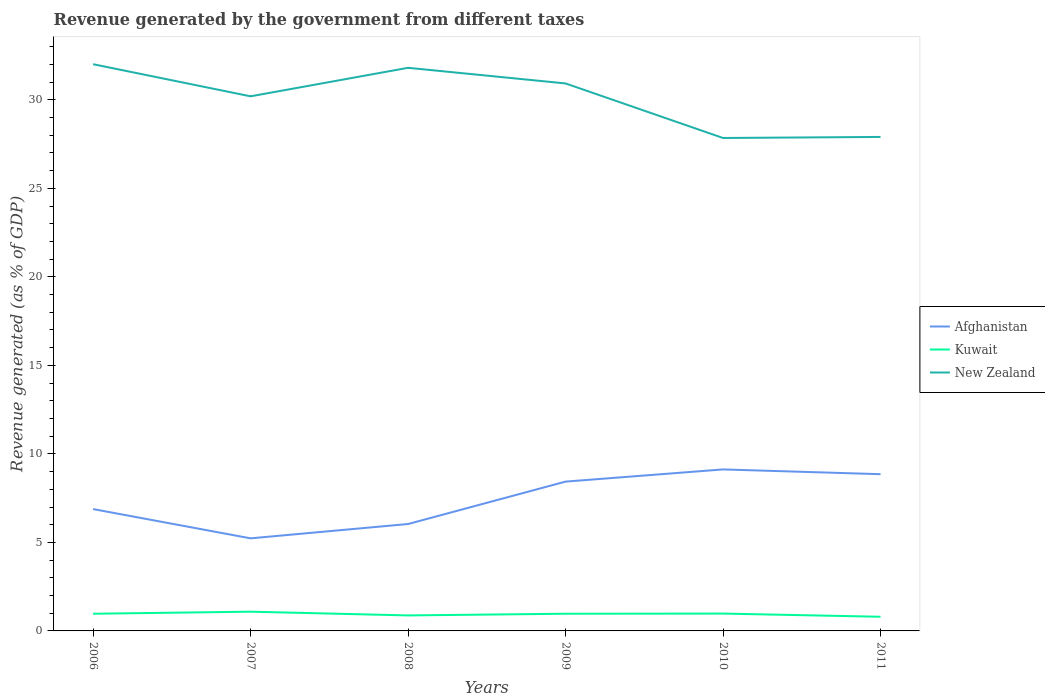How many different coloured lines are there?
Give a very brief answer. 3. Does the line corresponding to Kuwait intersect with the line corresponding to Afghanistan?
Ensure brevity in your answer.  No. Is the number of lines equal to the number of legend labels?
Offer a terse response. Yes. Across all years, what is the maximum revenue generated by the government in Kuwait?
Provide a short and direct response. 0.8. What is the total revenue generated by the government in Afghanistan in the graph?
Give a very brief answer. -1.55. What is the difference between the highest and the second highest revenue generated by the government in New Zealand?
Ensure brevity in your answer.  4.17. What is the difference between the highest and the lowest revenue generated by the government in Kuwait?
Offer a terse response. 4. What is the difference between two consecutive major ticks on the Y-axis?
Your answer should be very brief. 5. Does the graph contain grids?
Provide a short and direct response. No. Where does the legend appear in the graph?
Make the answer very short. Center right. How many legend labels are there?
Provide a short and direct response. 3. What is the title of the graph?
Ensure brevity in your answer.  Revenue generated by the government from different taxes. What is the label or title of the X-axis?
Ensure brevity in your answer.  Years. What is the label or title of the Y-axis?
Your answer should be compact. Revenue generated (as % of GDP). What is the Revenue generated (as % of GDP) of Afghanistan in 2006?
Offer a very short reply. 6.88. What is the Revenue generated (as % of GDP) in Kuwait in 2006?
Provide a short and direct response. 0.97. What is the Revenue generated (as % of GDP) of New Zealand in 2006?
Your response must be concise. 32.01. What is the Revenue generated (as % of GDP) of Afghanistan in 2007?
Give a very brief answer. 5.23. What is the Revenue generated (as % of GDP) in Kuwait in 2007?
Your answer should be very brief. 1.09. What is the Revenue generated (as % of GDP) in New Zealand in 2007?
Make the answer very short. 30.2. What is the Revenue generated (as % of GDP) of Afghanistan in 2008?
Offer a terse response. 6.04. What is the Revenue generated (as % of GDP) of Kuwait in 2008?
Ensure brevity in your answer.  0.88. What is the Revenue generated (as % of GDP) of New Zealand in 2008?
Ensure brevity in your answer.  31.81. What is the Revenue generated (as % of GDP) of Afghanistan in 2009?
Offer a very short reply. 8.43. What is the Revenue generated (as % of GDP) in Kuwait in 2009?
Ensure brevity in your answer.  0.97. What is the Revenue generated (as % of GDP) in New Zealand in 2009?
Provide a succinct answer. 30.93. What is the Revenue generated (as % of GDP) of Afghanistan in 2010?
Keep it short and to the point. 9.12. What is the Revenue generated (as % of GDP) of Kuwait in 2010?
Your answer should be very brief. 0.98. What is the Revenue generated (as % of GDP) of New Zealand in 2010?
Keep it short and to the point. 27.85. What is the Revenue generated (as % of GDP) in Afghanistan in 2011?
Offer a very short reply. 8.85. What is the Revenue generated (as % of GDP) of Kuwait in 2011?
Keep it short and to the point. 0.8. What is the Revenue generated (as % of GDP) in New Zealand in 2011?
Ensure brevity in your answer.  27.91. Across all years, what is the maximum Revenue generated (as % of GDP) in Afghanistan?
Keep it short and to the point. 9.12. Across all years, what is the maximum Revenue generated (as % of GDP) of Kuwait?
Your response must be concise. 1.09. Across all years, what is the maximum Revenue generated (as % of GDP) of New Zealand?
Provide a succinct answer. 32.01. Across all years, what is the minimum Revenue generated (as % of GDP) of Afghanistan?
Provide a succinct answer. 5.23. Across all years, what is the minimum Revenue generated (as % of GDP) in Kuwait?
Make the answer very short. 0.8. Across all years, what is the minimum Revenue generated (as % of GDP) of New Zealand?
Keep it short and to the point. 27.85. What is the total Revenue generated (as % of GDP) in Afghanistan in the graph?
Keep it short and to the point. 44.57. What is the total Revenue generated (as % of GDP) in Kuwait in the graph?
Make the answer very short. 5.68. What is the total Revenue generated (as % of GDP) of New Zealand in the graph?
Offer a terse response. 180.71. What is the difference between the Revenue generated (as % of GDP) of Afghanistan in 2006 and that in 2007?
Give a very brief answer. 1.65. What is the difference between the Revenue generated (as % of GDP) in Kuwait in 2006 and that in 2007?
Your answer should be very brief. -0.12. What is the difference between the Revenue generated (as % of GDP) of New Zealand in 2006 and that in 2007?
Provide a short and direct response. 1.81. What is the difference between the Revenue generated (as % of GDP) in Afghanistan in 2006 and that in 2008?
Provide a succinct answer. 0.84. What is the difference between the Revenue generated (as % of GDP) in Kuwait in 2006 and that in 2008?
Give a very brief answer. 0.09. What is the difference between the Revenue generated (as % of GDP) in New Zealand in 2006 and that in 2008?
Offer a very short reply. 0.2. What is the difference between the Revenue generated (as % of GDP) of Afghanistan in 2006 and that in 2009?
Keep it short and to the point. -1.55. What is the difference between the Revenue generated (as % of GDP) in Kuwait in 2006 and that in 2009?
Your response must be concise. -0. What is the difference between the Revenue generated (as % of GDP) in New Zealand in 2006 and that in 2009?
Give a very brief answer. 1.09. What is the difference between the Revenue generated (as % of GDP) in Afghanistan in 2006 and that in 2010?
Keep it short and to the point. -2.24. What is the difference between the Revenue generated (as % of GDP) of Kuwait in 2006 and that in 2010?
Make the answer very short. -0.01. What is the difference between the Revenue generated (as % of GDP) in New Zealand in 2006 and that in 2010?
Provide a short and direct response. 4.17. What is the difference between the Revenue generated (as % of GDP) of Afghanistan in 2006 and that in 2011?
Ensure brevity in your answer.  -1.97. What is the difference between the Revenue generated (as % of GDP) in Kuwait in 2006 and that in 2011?
Your answer should be very brief. 0.17. What is the difference between the Revenue generated (as % of GDP) in New Zealand in 2006 and that in 2011?
Offer a terse response. 4.11. What is the difference between the Revenue generated (as % of GDP) in Afghanistan in 2007 and that in 2008?
Make the answer very short. -0.81. What is the difference between the Revenue generated (as % of GDP) in Kuwait in 2007 and that in 2008?
Offer a terse response. 0.21. What is the difference between the Revenue generated (as % of GDP) in New Zealand in 2007 and that in 2008?
Provide a short and direct response. -1.61. What is the difference between the Revenue generated (as % of GDP) of Afghanistan in 2007 and that in 2009?
Offer a terse response. -3.21. What is the difference between the Revenue generated (as % of GDP) in Kuwait in 2007 and that in 2009?
Offer a terse response. 0.12. What is the difference between the Revenue generated (as % of GDP) of New Zealand in 2007 and that in 2009?
Provide a succinct answer. -0.73. What is the difference between the Revenue generated (as % of GDP) in Afghanistan in 2007 and that in 2010?
Your response must be concise. -3.89. What is the difference between the Revenue generated (as % of GDP) in Kuwait in 2007 and that in 2010?
Your answer should be very brief. 0.11. What is the difference between the Revenue generated (as % of GDP) of New Zealand in 2007 and that in 2010?
Ensure brevity in your answer.  2.35. What is the difference between the Revenue generated (as % of GDP) in Afghanistan in 2007 and that in 2011?
Your answer should be very brief. -3.62. What is the difference between the Revenue generated (as % of GDP) of Kuwait in 2007 and that in 2011?
Offer a terse response. 0.29. What is the difference between the Revenue generated (as % of GDP) in New Zealand in 2007 and that in 2011?
Keep it short and to the point. 2.29. What is the difference between the Revenue generated (as % of GDP) in Afghanistan in 2008 and that in 2009?
Provide a succinct answer. -2.4. What is the difference between the Revenue generated (as % of GDP) of Kuwait in 2008 and that in 2009?
Make the answer very short. -0.1. What is the difference between the Revenue generated (as % of GDP) of New Zealand in 2008 and that in 2009?
Ensure brevity in your answer.  0.88. What is the difference between the Revenue generated (as % of GDP) of Afghanistan in 2008 and that in 2010?
Give a very brief answer. -3.08. What is the difference between the Revenue generated (as % of GDP) of Kuwait in 2008 and that in 2010?
Keep it short and to the point. -0.1. What is the difference between the Revenue generated (as % of GDP) of New Zealand in 2008 and that in 2010?
Provide a short and direct response. 3.96. What is the difference between the Revenue generated (as % of GDP) in Afghanistan in 2008 and that in 2011?
Offer a very short reply. -2.82. What is the difference between the Revenue generated (as % of GDP) in Kuwait in 2008 and that in 2011?
Your response must be concise. 0.08. What is the difference between the Revenue generated (as % of GDP) of New Zealand in 2008 and that in 2011?
Your response must be concise. 3.91. What is the difference between the Revenue generated (as % of GDP) of Afghanistan in 2009 and that in 2010?
Make the answer very short. -0.69. What is the difference between the Revenue generated (as % of GDP) of Kuwait in 2009 and that in 2010?
Offer a terse response. -0.01. What is the difference between the Revenue generated (as % of GDP) in New Zealand in 2009 and that in 2010?
Your answer should be very brief. 3.08. What is the difference between the Revenue generated (as % of GDP) of Afghanistan in 2009 and that in 2011?
Ensure brevity in your answer.  -0.42. What is the difference between the Revenue generated (as % of GDP) of Kuwait in 2009 and that in 2011?
Offer a very short reply. 0.17. What is the difference between the Revenue generated (as % of GDP) of New Zealand in 2009 and that in 2011?
Your response must be concise. 3.02. What is the difference between the Revenue generated (as % of GDP) in Afghanistan in 2010 and that in 2011?
Give a very brief answer. 0.27. What is the difference between the Revenue generated (as % of GDP) in Kuwait in 2010 and that in 2011?
Your answer should be compact. 0.18. What is the difference between the Revenue generated (as % of GDP) of New Zealand in 2010 and that in 2011?
Ensure brevity in your answer.  -0.06. What is the difference between the Revenue generated (as % of GDP) in Afghanistan in 2006 and the Revenue generated (as % of GDP) in Kuwait in 2007?
Make the answer very short. 5.8. What is the difference between the Revenue generated (as % of GDP) in Afghanistan in 2006 and the Revenue generated (as % of GDP) in New Zealand in 2007?
Make the answer very short. -23.32. What is the difference between the Revenue generated (as % of GDP) of Kuwait in 2006 and the Revenue generated (as % of GDP) of New Zealand in 2007?
Your response must be concise. -29.23. What is the difference between the Revenue generated (as % of GDP) of Afghanistan in 2006 and the Revenue generated (as % of GDP) of Kuwait in 2008?
Your response must be concise. 6.01. What is the difference between the Revenue generated (as % of GDP) in Afghanistan in 2006 and the Revenue generated (as % of GDP) in New Zealand in 2008?
Offer a terse response. -24.93. What is the difference between the Revenue generated (as % of GDP) in Kuwait in 2006 and the Revenue generated (as % of GDP) in New Zealand in 2008?
Offer a very short reply. -30.84. What is the difference between the Revenue generated (as % of GDP) in Afghanistan in 2006 and the Revenue generated (as % of GDP) in Kuwait in 2009?
Provide a succinct answer. 5.91. What is the difference between the Revenue generated (as % of GDP) of Afghanistan in 2006 and the Revenue generated (as % of GDP) of New Zealand in 2009?
Give a very brief answer. -24.05. What is the difference between the Revenue generated (as % of GDP) of Kuwait in 2006 and the Revenue generated (as % of GDP) of New Zealand in 2009?
Your answer should be compact. -29.96. What is the difference between the Revenue generated (as % of GDP) of Afghanistan in 2006 and the Revenue generated (as % of GDP) of Kuwait in 2010?
Give a very brief answer. 5.9. What is the difference between the Revenue generated (as % of GDP) of Afghanistan in 2006 and the Revenue generated (as % of GDP) of New Zealand in 2010?
Make the answer very short. -20.96. What is the difference between the Revenue generated (as % of GDP) of Kuwait in 2006 and the Revenue generated (as % of GDP) of New Zealand in 2010?
Your response must be concise. -26.88. What is the difference between the Revenue generated (as % of GDP) of Afghanistan in 2006 and the Revenue generated (as % of GDP) of Kuwait in 2011?
Provide a succinct answer. 6.08. What is the difference between the Revenue generated (as % of GDP) of Afghanistan in 2006 and the Revenue generated (as % of GDP) of New Zealand in 2011?
Your answer should be compact. -21.02. What is the difference between the Revenue generated (as % of GDP) in Kuwait in 2006 and the Revenue generated (as % of GDP) in New Zealand in 2011?
Offer a very short reply. -26.94. What is the difference between the Revenue generated (as % of GDP) of Afghanistan in 2007 and the Revenue generated (as % of GDP) of Kuwait in 2008?
Offer a terse response. 4.35. What is the difference between the Revenue generated (as % of GDP) in Afghanistan in 2007 and the Revenue generated (as % of GDP) in New Zealand in 2008?
Make the answer very short. -26.58. What is the difference between the Revenue generated (as % of GDP) of Kuwait in 2007 and the Revenue generated (as % of GDP) of New Zealand in 2008?
Your response must be concise. -30.72. What is the difference between the Revenue generated (as % of GDP) of Afghanistan in 2007 and the Revenue generated (as % of GDP) of Kuwait in 2009?
Offer a terse response. 4.26. What is the difference between the Revenue generated (as % of GDP) of Afghanistan in 2007 and the Revenue generated (as % of GDP) of New Zealand in 2009?
Provide a succinct answer. -25.7. What is the difference between the Revenue generated (as % of GDP) in Kuwait in 2007 and the Revenue generated (as % of GDP) in New Zealand in 2009?
Your answer should be very brief. -29.84. What is the difference between the Revenue generated (as % of GDP) of Afghanistan in 2007 and the Revenue generated (as % of GDP) of Kuwait in 2010?
Your response must be concise. 4.25. What is the difference between the Revenue generated (as % of GDP) of Afghanistan in 2007 and the Revenue generated (as % of GDP) of New Zealand in 2010?
Your answer should be very brief. -22.62. What is the difference between the Revenue generated (as % of GDP) of Kuwait in 2007 and the Revenue generated (as % of GDP) of New Zealand in 2010?
Ensure brevity in your answer.  -26.76. What is the difference between the Revenue generated (as % of GDP) in Afghanistan in 2007 and the Revenue generated (as % of GDP) in Kuwait in 2011?
Make the answer very short. 4.43. What is the difference between the Revenue generated (as % of GDP) of Afghanistan in 2007 and the Revenue generated (as % of GDP) of New Zealand in 2011?
Your answer should be compact. -22.68. What is the difference between the Revenue generated (as % of GDP) of Kuwait in 2007 and the Revenue generated (as % of GDP) of New Zealand in 2011?
Ensure brevity in your answer.  -26.82. What is the difference between the Revenue generated (as % of GDP) of Afghanistan in 2008 and the Revenue generated (as % of GDP) of Kuwait in 2009?
Provide a succinct answer. 5.07. What is the difference between the Revenue generated (as % of GDP) of Afghanistan in 2008 and the Revenue generated (as % of GDP) of New Zealand in 2009?
Ensure brevity in your answer.  -24.89. What is the difference between the Revenue generated (as % of GDP) of Kuwait in 2008 and the Revenue generated (as % of GDP) of New Zealand in 2009?
Your answer should be compact. -30.05. What is the difference between the Revenue generated (as % of GDP) of Afghanistan in 2008 and the Revenue generated (as % of GDP) of Kuwait in 2010?
Make the answer very short. 5.06. What is the difference between the Revenue generated (as % of GDP) of Afghanistan in 2008 and the Revenue generated (as % of GDP) of New Zealand in 2010?
Your answer should be compact. -21.81. What is the difference between the Revenue generated (as % of GDP) in Kuwait in 2008 and the Revenue generated (as % of GDP) in New Zealand in 2010?
Ensure brevity in your answer.  -26.97. What is the difference between the Revenue generated (as % of GDP) of Afghanistan in 2008 and the Revenue generated (as % of GDP) of Kuwait in 2011?
Your answer should be compact. 5.24. What is the difference between the Revenue generated (as % of GDP) of Afghanistan in 2008 and the Revenue generated (as % of GDP) of New Zealand in 2011?
Keep it short and to the point. -21.87. What is the difference between the Revenue generated (as % of GDP) in Kuwait in 2008 and the Revenue generated (as % of GDP) in New Zealand in 2011?
Ensure brevity in your answer.  -27.03. What is the difference between the Revenue generated (as % of GDP) in Afghanistan in 2009 and the Revenue generated (as % of GDP) in Kuwait in 2010?
Keep it short and to the point. 7.46. What is the difference between the Revenue generated (as % of GDP) of Afghanistan in 2009 and the Revenue generated (as % of GDP) of New Zealand in 2010?
Offer a terse response. -19.41. What is the difference between the Revenue generated (as % of GDP) of Kuwait in 2009 and the Revenue generated (as % of GDP) of New Zealand in 2010?
Offer a terse response. -26.88. What is the difference between the Revenue generated (as % of GDP) of Afghanistan in 2009 and the Revenue generated (as % of GDP) of Kuwait in 2011?
Offer a very short reply. 7.64. What is the difference between the Revenue generated (as % of GDP) of Afghanistan in 2009 and the Revenue generated (as % of GDP) of New Zealand in 2011?
Your answer should be very brief. -19.47. What is the difference between the Revenue generated (as % of GDP) in Kuwait in 2009 and the Revenue generated (as % of GDP) in New Zealand in 2011?
Your answer should be very brief. -26.93. What is the difference between the Revenue generated (as % of GDP) of Afghanistan in 2010 and the Revenue generated (as % of GDP) of Kuwait in 2011?
Your answer should be very brief. 8.32. What is the difference between the Revenue generated (as % of GDP) in Afghanistan in 2010 and the Revenue generated (as % of GDP) in New Zealand in 2011?
Offer a terse response. -18.78. What is the difference between the Revenue generated (as % of GDP) in Kuwait in 2010 and the Revenue generated (as % of GDP) in New Zealand in 2011?
Your response must be concise. -26.93. What is the average Revenue generated (as % of GDP) of Afghanistan per year?
Give a very brief answer. 7.43. What is the average Revenue generated (as % of GDP) of Kuwait per year?
Keep it short and to the point. 0.95. What is the average Revenue generated (as % of GDP) in New Zealand per year?
Your response must be concise. 30.12. In the year 2006, what is the difference between the Revenue generated (as % of GDP) of Afghanistan and Revenue generated (as % of GDP) of Kuwait?
Offer a terse response. 5.91. In the year 2006, what is the difference between the Revenue generated (as % of GDP) of Afghanistan and Revenue generated (as % of GDP) of New Zealand?
Your answer should be very brief. -25.13. In the year 2006, what is the difference between the Revenue generated (as % of GDP) in Kuwait and Revenue generated (as % of GDP) in New Zealand?
Your answer should be very brief. -31.04. In the year 2007, what is the difference between the Revenue generated (as % of GDP) of Afghanistan and Revenue generated (as % of GDP) of Kuwait?
Your answer should be very brief. 4.14. In the year 2007, what is the difference between the Revenue generated (as % of GDP) of Afghanistan and Revenue generated (as % of GDP) of New Zealand?
Ensure brevity in your answer.  -24.97. In the year 2007, what is the difference between the Revenue generated (as % of GDP) of Kuwait and Revenue generated (as % of GDP) of New Zealand?
Your response must be concise. -29.11. In the year 2008, what is the difference between the Revenue generated (as % of GDP) of Afghanistan and Revenue generated (as % of GDP) of Kuwait?
Ensure brevity in your answer.  5.16. In the year 2008, what is the difference between the Revenue generated (as % of GDP) in Afghanistan and Revenue generated (as % of GDP) in New Zealand?
Make the answer very short. -25.77. In the year 2008, what is the difference between the Revenue generated (as % of GDP) in Kuwait and Revenue generated (as % of GDP) in New Zealand?
Offer a very short reply. -30.94. In the year 2009, what is the difference between the Revenue generated (as % of GDP) in Afghanistan and Revenue generated (as % of GDP) in Kuwait?
Your answer should be compact. 7.46. In the year 2009, what is the difference between the Revenue generated (as % of GDP) of Afghanistan and Revenue generated (as % of GDP) of New Zealand?
Provide a succinct answer. -22.49. In the year 2009, what is the difference between the Revenue generated (as % of GDP) in Kuwait and Revenue generated (as % of GDP) in New Zealand?
Make the answer very short. -29.96. In the year 2010, what is the difference between the Revenue generated (as % of GDP) of Afghanistan and Revenue generated (as % of GDP) of Kuwait?
Provide a succinct answer. 8.14. In the year 2010, what is the difference between the Revenue generated (as % of GDP) of Afghanistan and Revenue generated (as % of GDP) of New Zealand?
Your response must be concise. -18.72. In the year 2010, what is the difference between the Revenue generated (as % of GDP) of Kuwait and Revenue generated (as % of GDP) of New Zealand?
Your answer should be compact. -26.87. In the year 2011, what is the difference between the Revenue generated (as % of GDP) of Afghanistan and Revenue generated (as % of GDP) of Kuwait?
Offer a terse response. 8.05. In the year 2011, what is the difference between the Revenue generated (as % of GDP) of Afghanistan and Revenue generated (as % of GDP) of New Zealand?
Give a very brief answer. -19.05. In the year 2011, what is the difference between the Revenue generated (as % of GDP) of Kuwait and Revenue generated (as % of GDP) of New Zealand?
Give a very brief answer. -27.11. What is the ratio of the Revenue generated (as % of GDP) in Afghanistan in 2006 to that in 2007?
Provide a succinct answer. 1.32. What is the ratio of the Revenue generated (as % of GDP) in Kuwait in 2006 to that in 2007?
Make the answer very short. 0.89. What is the ratio of the Revenue generated (as % of GDP) of New Zealand in 2006 to that in 2007?
Your response must be concise. 1.06. What is the ratio of the Revenue generated (as % of GDP) of Afghanistan in 2006 to that in 2008?
Make the answer very short. 1.14. What is the ratio of the Revenue generated (as % of GDP) of Kuwait in 2006 to that in 2008?
Provide a short and direct response. 1.11. What is the ratio of the Revenue generated (as % of GDP) of New Zealand in 2006 to that in 2008?
Make the answer very short. 1.01. What is the ratio of the Revenue generated (as % of GDP) of Afghanistan in 2006 to that in 2009?
Ensure brevity in your answer.  0.82. What is the ratio of the Revenue generated (as % of GDP) of Kuwait in 2006 to that in 2009?
Provide a short and direct response. 1. What is the ratio of the Revenue generated (as % of GDP) in New Zealand in 2006 to that in 2009?
Provide a short and direct response. 1.04. What is the ratio of the Revenue generated (as % of GDP) in Afghanistan in 2006 to that in 2010?
Give a very brief answer. 0.75. What is the ratio of the Revenue generated (as % of GDP) of Kuwait in 2006 to that in 2010?
Provide a succinct answer. 0.99. What is the ratio of the Revenue generated (as % of GDP) of New Zealand in 2006 to that in 2010?
Provide a succinct answer. 1.15. What is the ratio of the Revenue generated (as % of GDP) in Afghanistan in 2006 to that in 2011?
Your answer should be very brief. 0.78. What is the ratio of the Revenue generated (as % of GDP) in Kuwait in 2006 to that in 2011?
Provide a short and direct response. 1.21. What is the ratio of the Revenue generated (as % of GDP) of New Zealand in 2006 to that in 2011?
Offer a terse response. 1.15. What is the ratio of the Revenue generated (as % of GDP) of Afghanistan in 2007 to that in 2008?
Keep it short and to the point. 0.87. What is the ratio of the Revenue generated (as % of GDP) of Kuwait in 2007 to that in 2008?
Your answer should be compact. 1.24. What is the ratio of the Revenue generated (as % of GDP) in New Zealand in 2007 to that in 2008?
Offer a very short reply. 0.95. What is the ratio of the Revenue generated (as % of GDP) of Afghanistan in 2007 to that in 2009?
Your response must be concise. 0.62. What is the ratio of the Revenue generated (as % of GDP) in Kuwait in 2007 to that in 2009?
Keep it short and to the point. 1.12. What is the ratio of the Revenue generated (as % of GDP) in New Zealand in 2007 to that in 2009?
Offer a very short reply. 0.98. What is the ratio of the Revenue generated (as % of GDP) in Afghanistan in 2007 to that in 2010?
Your answer should be very brief. 0.57. What is the ratio of the Revenue generated (as % of GDP) in Kuwait in 2007 to that in 2010?
Your response must be concise. 1.11. What is the ratio of the Revenue generated (as % of GDP) in New Zealand in 2007 to that in 2010?
Provide a succinct answer. 1.08. What is the ratio of the Revenue generated (as % of GDP) of Afghanistan in 2007 to that in 2011?
Make the answer very short. 0.59. What is the ratio of the Revenue generated (as % of GDP) of Kuwait in 2007 to that in 2011?
Keep it short and to the point. 1.36. What is the ratio of the Revenue generated (as % of GDP) in New Zealand in 2007 to that in 2011?
Your answer should be compact. 1.08. What is the ratio of the Revenue generated (as % of GDP) of Afghanistan in 2008 to that in 2009?
Keep it short and to the point. 0.72. What is the ratio of the Revenue generated (as % of GDP) in Kuwait in 2008 to that in 2009?
Make the answer very short. 0.9. What is the ratio of the Revenue generated (as % of GDP) of New Zealand in 2008 to that in 2009?
Make the answer very short. 1.03. What is the ratio of the Revenue generated (as % of GDP) in Afghanistan in 2008 to that in 2010?
Your response must be concise. 0.66. What is the ratio of the Revenue generated (as % of GDP) in Kuwait in 2008 to that in 2010?
Your answer should be very brief. 0.89. What is the ratio of the Revenue generated (as % of GDP) of New Zealand in 2008 to that in 2010?
Offer a terse response. 1.14. What is the ratio of the Revenue generated (as % of GDP) of Afghanistan in 2008 to that in 2011?
Keep it short and to the point. 0.68. What is the ratio of the Revenue generated (as % of GDP) in Kuwait in 2008 to that in 2011?
Provide a short and direct response. 1.1. What is the ratio of the Revenue generated (as % of GDP) of New Zealand in 2008 to that in 2011?
Your answer should be compact. 1.14. What is the ratio of the Revenue generated (as % of GDP) of Afghanistan in 2009 to that in 2010?
Offer a terse response. 0.92. What is the ratio of the Revenue generated (as % of GDP) of Kuwait in 2009 to that in 2010?
Your answer should be compact. 0.99. What is the ratio of the Revenue generated (as % of GDP) of New Zealand in 2009 to that in 2010?
Give a very brief answer. 1.11. What is the ratio of the Revenue generated (as % of GDP) of Afghanistan in 2009 to that in 2011?
Your answer should be compact. 0.95. What is the ratio of the Revenue generated (as % of GDP) in Kuwait in 2009 to that in 2011?
Ensure brevity in your answer.  1.21. What is the ratio of the Revenue generated (as % of GDP) of New Zealand in 2009 to that in 2011?
Keep it short and to the point. 1.11. What is the ratio of the Revenue generated (as % of GDP) of Afghanistan in 2010 to that in 2011?
Your answer should be compact. 1.03. What is the ratio of the Revenue generated (as % of GDP) in Kuwait in 2010 to that in 2011?
Provide a short and direct response. 1.22. What is the difference between the highest and the second highest Revenue generated (as % of GDP) in Afghanistan?
Offer a terse response. 0.27. What is the difference between the highest and the second highest Revenue generated (as % of GDP) of Kuwait?
Give a very brief answer. 0.11. What is the difference between the highest and the second highest Revenue generated (as % of GDP) of New Zealand?
Offer a terse response. 0.2. What is the difference between the highest and the lowest Revenue generated (as % of GDP) in Afghanistan?
Provide a short and direct response. 3.89. What is the difference between the highest and the lowest Revenue generated (as % of GDP) of Kuwait?
Offer a very short reply. 0.29. What is the difference between the highest and the lowest Revenue generated (as % of GDP) in New Zealand?
Provide a short and direct response. 4.17. 